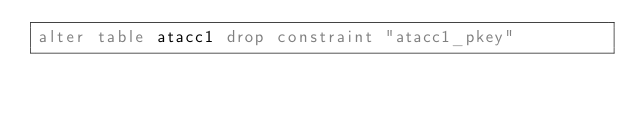<code> <loc_0><loc_0><loc_500><loc_500><_SQL_>alter table atacc1 drop constraint "atacc1_pkey"
</code> 